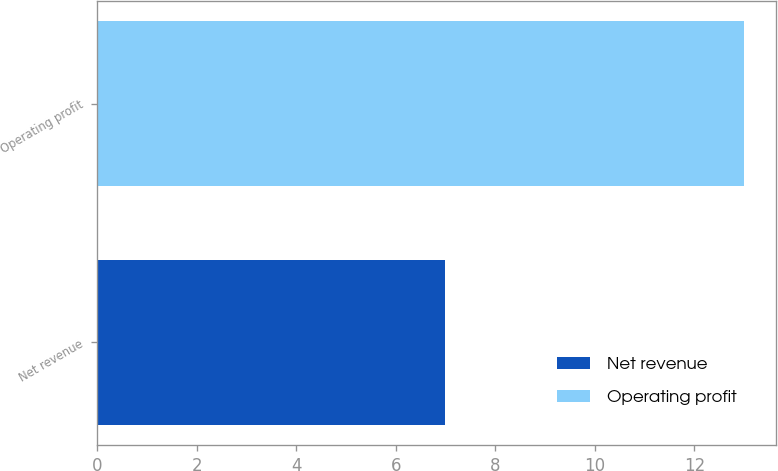Convert chart to OTSL. <chart><loc_0><loc_0><loc_500><loc_500><bar_chart><fcel>Net revenue<fcel>Operating profit<nl><fcel>7<fcel>13<nl></chart> 